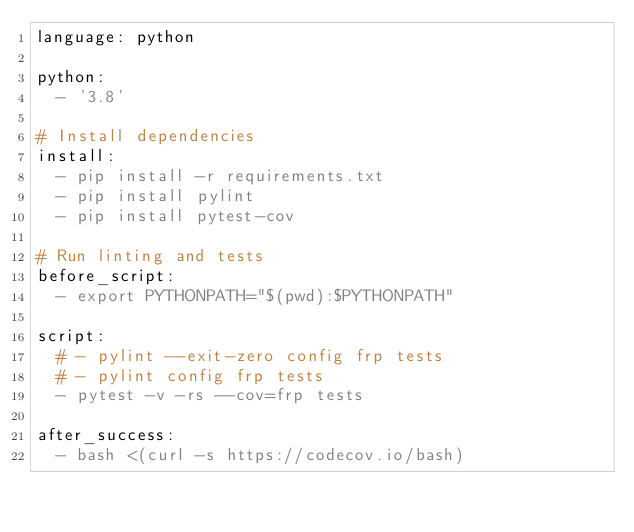<code> <loc_0><loc_0><loc_500><loc_500><_YAML_>language: python

python:
  - '3.8'

# Install dependencies
install:
  - pip install -r requirements.txt
  - pip install pylint
  - pip install pytest-cov

# Run linting and tests
before_script:
  - export PYTHONPATH="$(pwd):$PYTHONPATH"

script:
  # - pylint --exit-zero config frp tests
  # - pylint config frp tests
  - pytest -v -rs --cov=frp tests

after_success:
  - bash <(curl -s https://codecov.io/bash)
</code> 